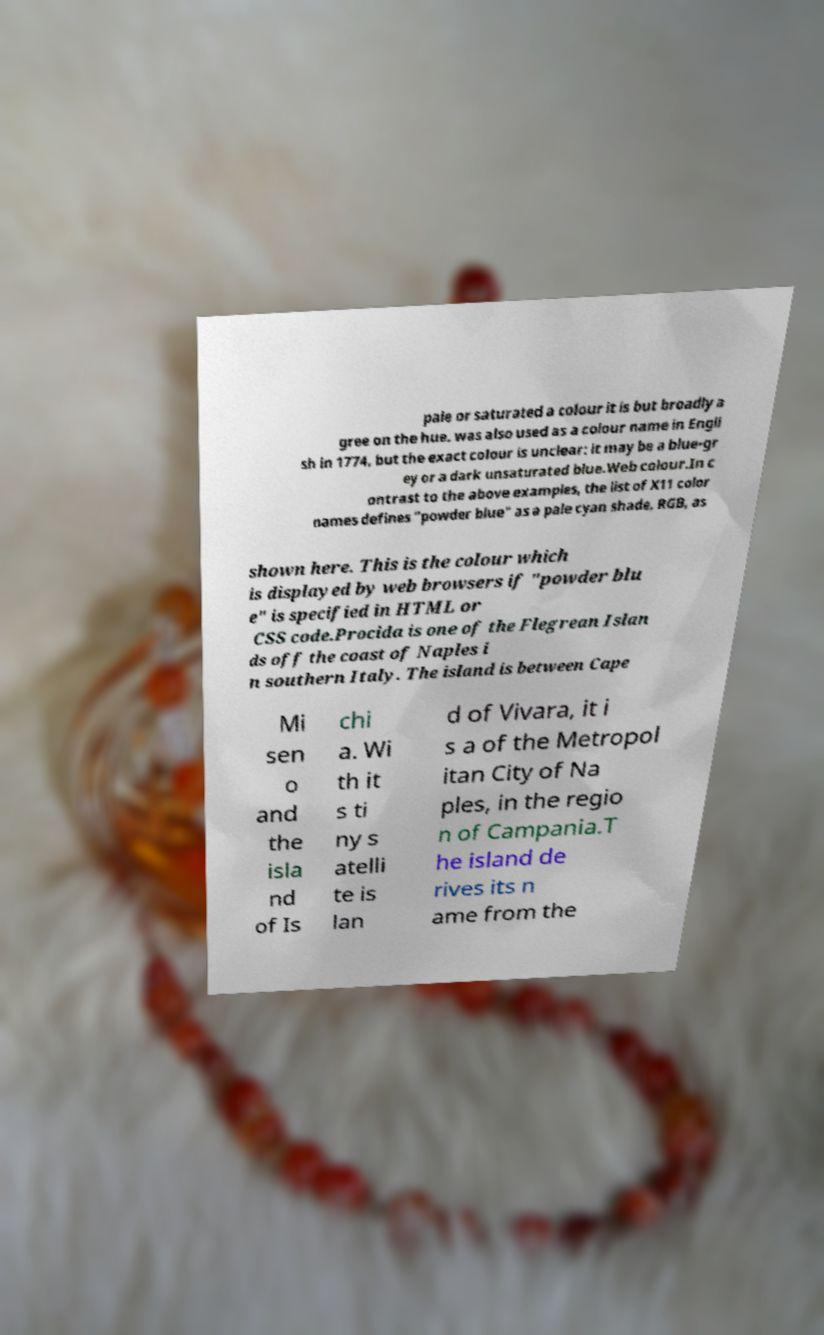Please identify and transcribe the text found in this image. pale or saturated a colour it is but broadly a gree on the hue. was also used as a colour name in Engli sh in 1774, but the exact colour is unclear: it may be a blue-gr ey or a dark unsaturated blue.Web colour.In c ontrast to the above examples, the list of X11 color names defines "powder blue" as a pale cyan shade, RGB, as shown here. This is the colour which is displayed by web browsers if "powder blu e" is specified in HTML or CSS code.Procida is one of the Flegrean Islan ds off the coast of Naples i n southern Italy. The island is between Cape Mi sen o and the isla nd of Is chi a. Wi th it s ti ny s atelli te is lan d of Vivara, it i s a of the Metropol itan City of Na ples, in the regio n of Campania.T he island de rives its n ame from the 